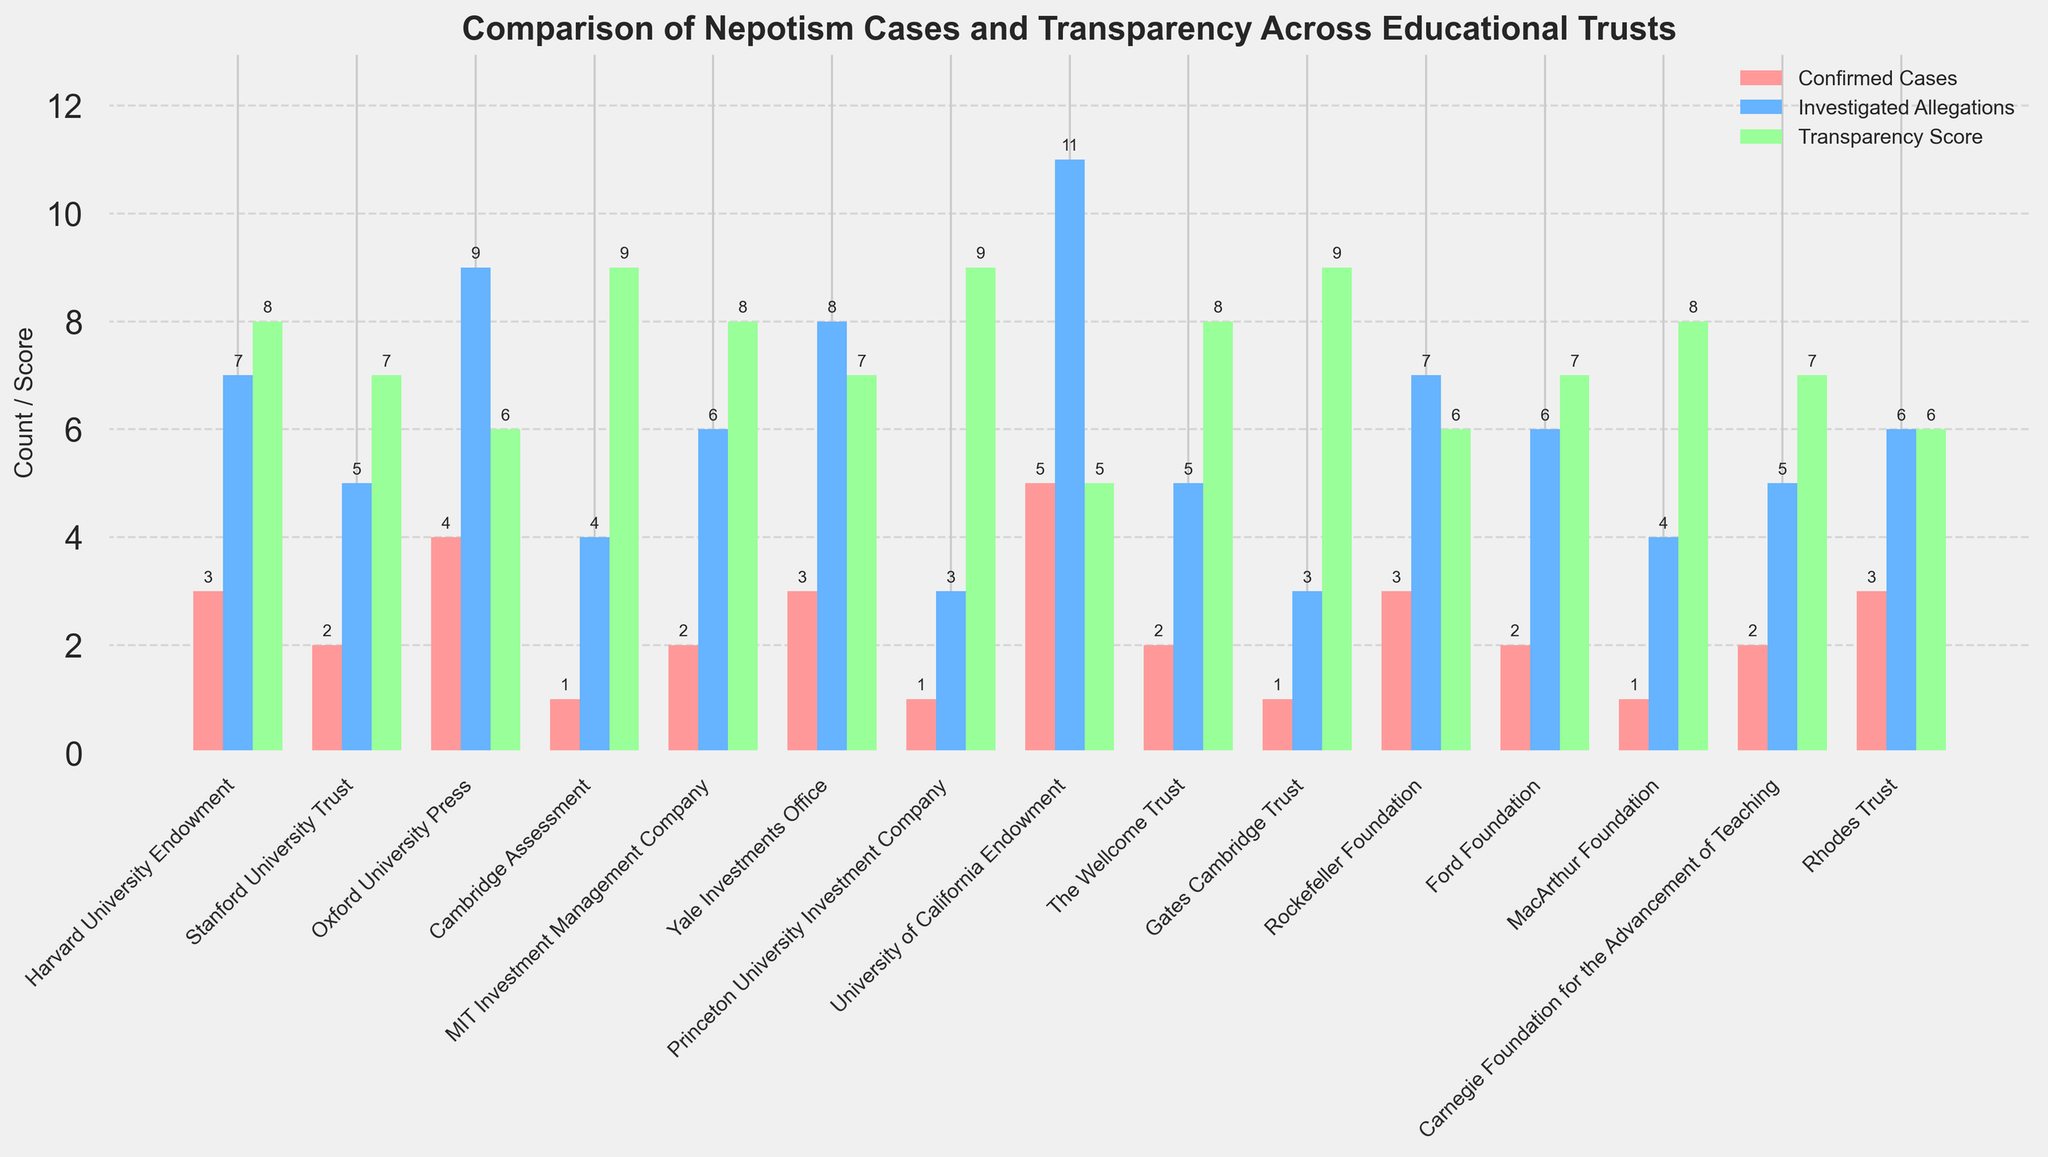How many more nepotism cases were confirmed at the University of California Endowment compared to Cambridge Assessment? The University of California Endowment has 5 confirmed nepotism cases, while Cambridge Assessment has 1. The difference is 5 - 1.
Answer: 4 Which educational trust has the highest investigated allegations? The University of California Endowment has the highest investigated allegations with 11 cases.
Answer: University of California Endowment What is the average transparency score of all educational trusts shown? Sum up all the transparency scores (8+7+6+9+8+7+9+5+8+9+6+7+8+7+6=106) and divide by the number of trusts (15). The average is 106 / 15.
Answer: 7.07 Which educational trust has both the lowest confirmed nepotism cases and the highest transparency score? Cambridge Assessment has the lowest confirmed nepotism cases (1) and is tied with Gates Cambridge Trust and Princeton University Investment Company for the highest transparency score (9).
Answer: Cambridge Assessment How many educational trusts have a transparency score of 8 or higher? Iterate through the list and count the trusts with a transparency score of 8 or higher: Harvard University Endowment, Cambridge Assessment, MIT Investment Management Company, The Wellcome Trust, Gates Cambridge Trust, MacArthur Foundation, Princeton University Investment Company. There are 7.
Answer: 7 Compare the number of confirmed nepotism cases between Oxford University Press and Rhodes Trust. Which one has more, and by how many? Oxford University Press has 4 confirmed nepotism cases, and Rhodes Trust has 3. 4 - 3 = 1. Oxford University Press has 1 more case.
Answer: Oxford University Press, 1 Which educational trust has equal numbers of confirmed nepotism cases and transparency scores? There is no educational trust where the number of confirmed nepotism cases is equal to the transparency score.
Answer: None What is the total number of investigated allegations for Harvard University Endowment, Stanford University Trust, and Yale Investments Office combined? Harvard University Endowment has 7, Stanford University Trust has 5, and Yale Investments Office has 8 investigated allegations. The sum is 7 + 5 + 8.
Answer: 20 What is the difference in the transparency scores between the highest and the lowest scoring educational trusts? The highest transparency score is 9 (Cambridge Assessment, Princeton University Investment Company, and Gates Cambridge Trust), and the lowest is 5 (University of California Endowment). 9 - 5 = 4.
Answer: 4 Which educational trust with more than 3 investigated allegations has the highest transparency score? Cambridge Assessment has 4 investigated allegations and a transparency score of 9, which is the highest among trusts with more than 3 investigated allegations.
Answer: Cambridge Assessment 